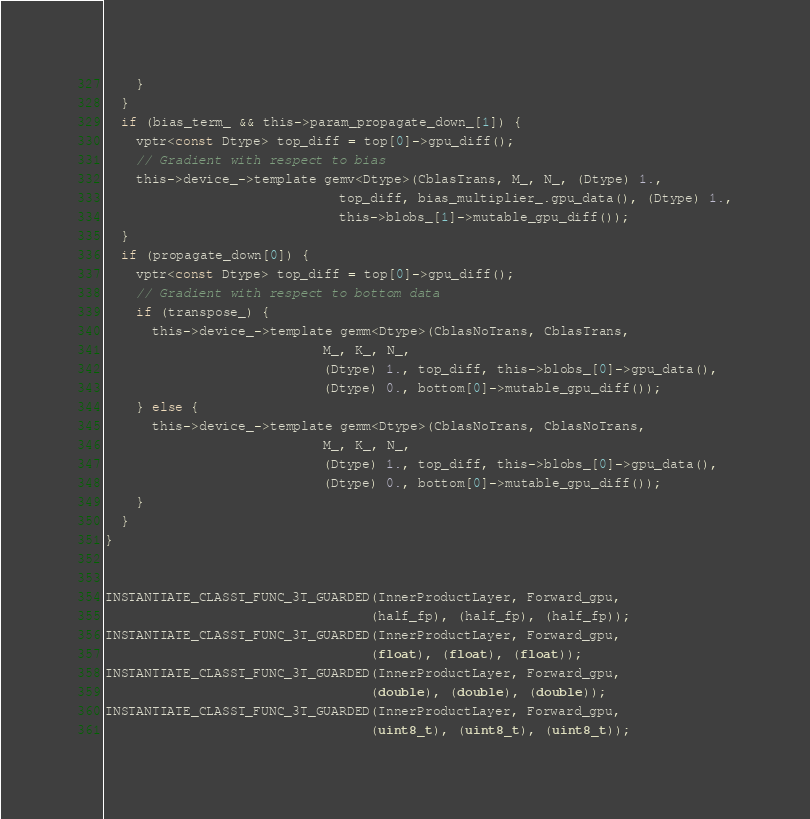Convert code to text. <code><loc_0><loc_0><loc_500><loc_500><_Cuda_>    }
  }
  if (bias_term_ && this->param_propagate_down_[1]) {
    vptr<const Dtype> top_diff = top[0]->gpu_diff();
    // Gradient with respect to bias
    this->device_->template gemv<Dtype>(CblasTrans, M_, N_, (Dtype) 1.,
                              top_diff, bias_multiplier_.gpu_data(), (Dtype) 1.,
                              this->blobs_[1]->mutable_gpu_diff());
  }
  if (propagate_down[0]) {
    vptr<const Dtype> top_diff = top[0]->gpu_diff();
    // Gradient with respect to bottom data
    if (transpose_) {
      this->device_->template gemm<Dtype>(CblasNoTrans, CblasTrans,
                            M_, K_, N_,
                            (Dtype) 1., top_diff, this->blobs_[0]->gpu_data(),
                            (Dtype) 0., bottom[0]->mutable_gpu_diff());
    } else {
      this->device_->template gemm<Dtype>(CblasNoTrans, CblasNoTrans,
                            M_, K_, N_,
                            (Dtype) 1., top_diff, this->blobs_[0]->gpu_data(),
                            (Dtype) 0., bottom[0]->mutable_gpu_diff());
    }
  }
}


INSTANTIATE_CLASST_FUNC_3T_GUARDED(InnerProductLayer, Forward_gpu,
                                  (half_fp), (half_fp), (half_fp));
INSTANTIATE_CLASST_FUNC_3T_GUARDED(InnerProductLayer, Forward_gpu,
                                  (float), (float), (float));
INSTANTIATE_CLASST_FUNC_3T_GUARDED(InnerProductLayer, Forward_gpu,
                                  (double), (double), (double));
INSTANTIATE_CLASST_FUNC_3T_GUARDED(InnerProductLayer, Forward_gpu,
                                  (uint8_t), (uint8_t), (uint8_t));</code> 